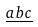<formula> <loc_0><loc_0><loc_500><loc_500>\underline { a b c }</formula> 